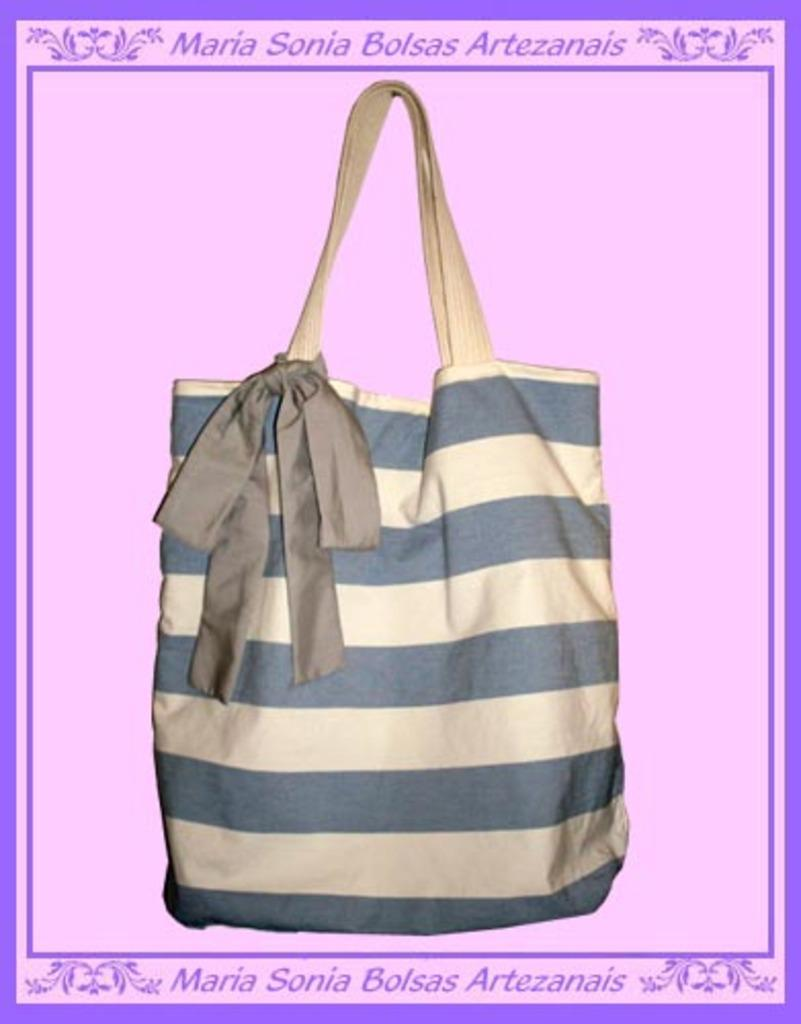What object can be seen in the picture? There is a bag in the picture. Can you describe the design of the bag? The bag has a striped design. What color is the background of the image? The background of the image is pink. What type of egg is being used in the class process depicted in the image? There is no class or process involving eggs present in the image; it only features a bag with a striped design against a pink background. 